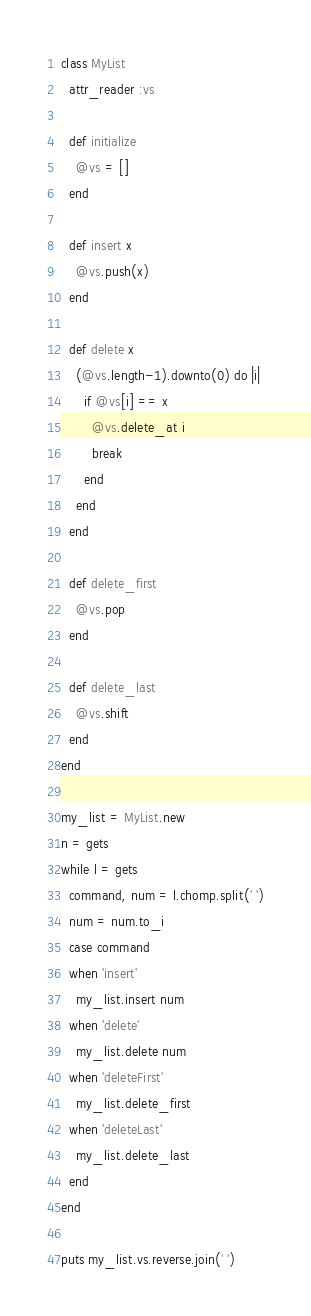<code> <loc_0><loc_0><loc_500><loc_500><_Ruby_>class MyList
  attr_reader :vs

  def initialize
    @vs = []
  end

  def insert x
    @vs.push(x)
  end

  def delete x
    (@vs.length-1).downto(0) do |i|
      if @vs[i] == x
        @vs.delete_at i
        break
      end
    end
  end

  def delete_first
    @vs.pop
  end

  def delete_last
    @vs.shift
  end
end

my_list = MyList.new
n = gets
while l = gets
  command, num = l.chomp.split(' ')
  num = num.to_i
  case command
  when 'insert'
    my_list.insert num
  when 'delete'
    my_list.delete num
  when 'deleteFirst'
    my_list.delete_first
  when 'deleteLast'
    my_list.delete_last
  end
end

puts my_list.vs.reverse.join(' ')
</code> 